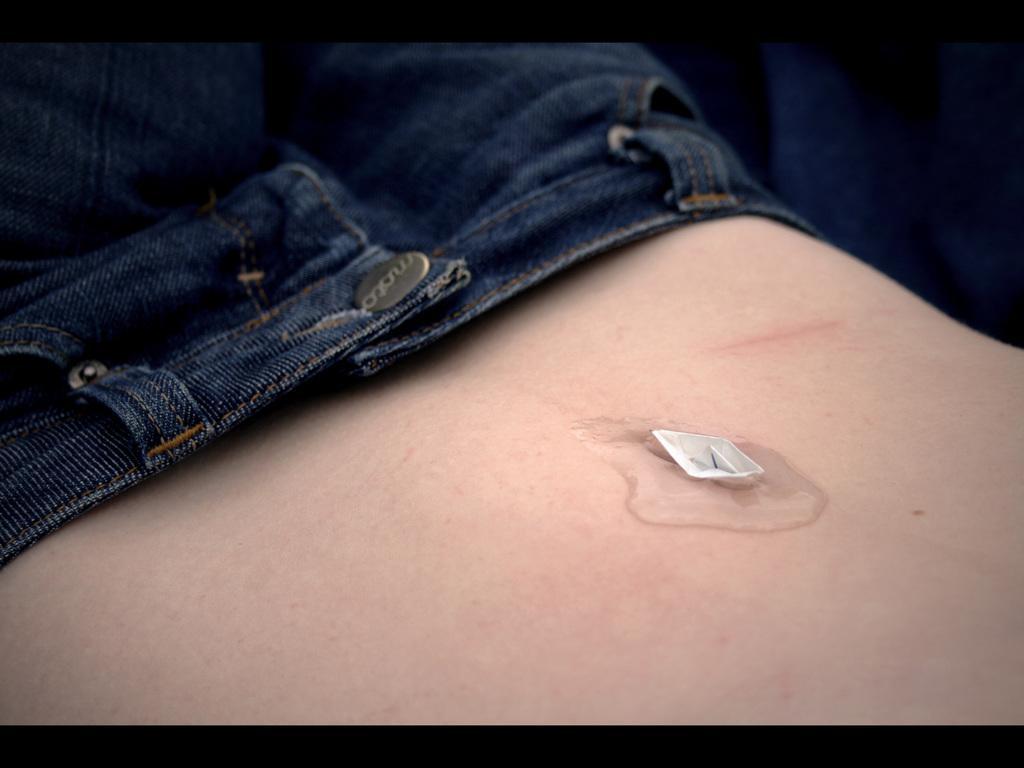How would you summarize this image in a sentence or two? In this picture I can see there is a person wearing jeans and there is a paper boat hire. 